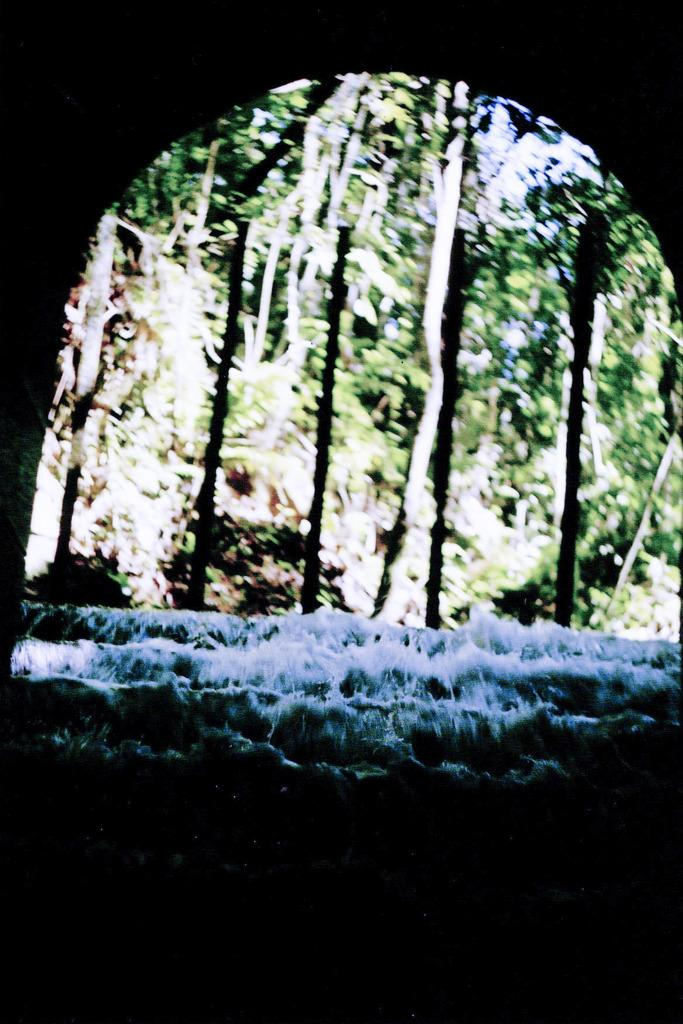What structure is present in the image? There is an arch in the image. What can be seen in the center of the image? There is water flow in the center of the image. What type of vegetation is visible in the background of the image? There are many trees, plants, and grass in the background of the image. How would you describe the lighting at the bottom of the image? The bottom of the image appears to be dark. What type of trail can be seen leading to the cannon in the image? There is no trail or cannon present in the image. 